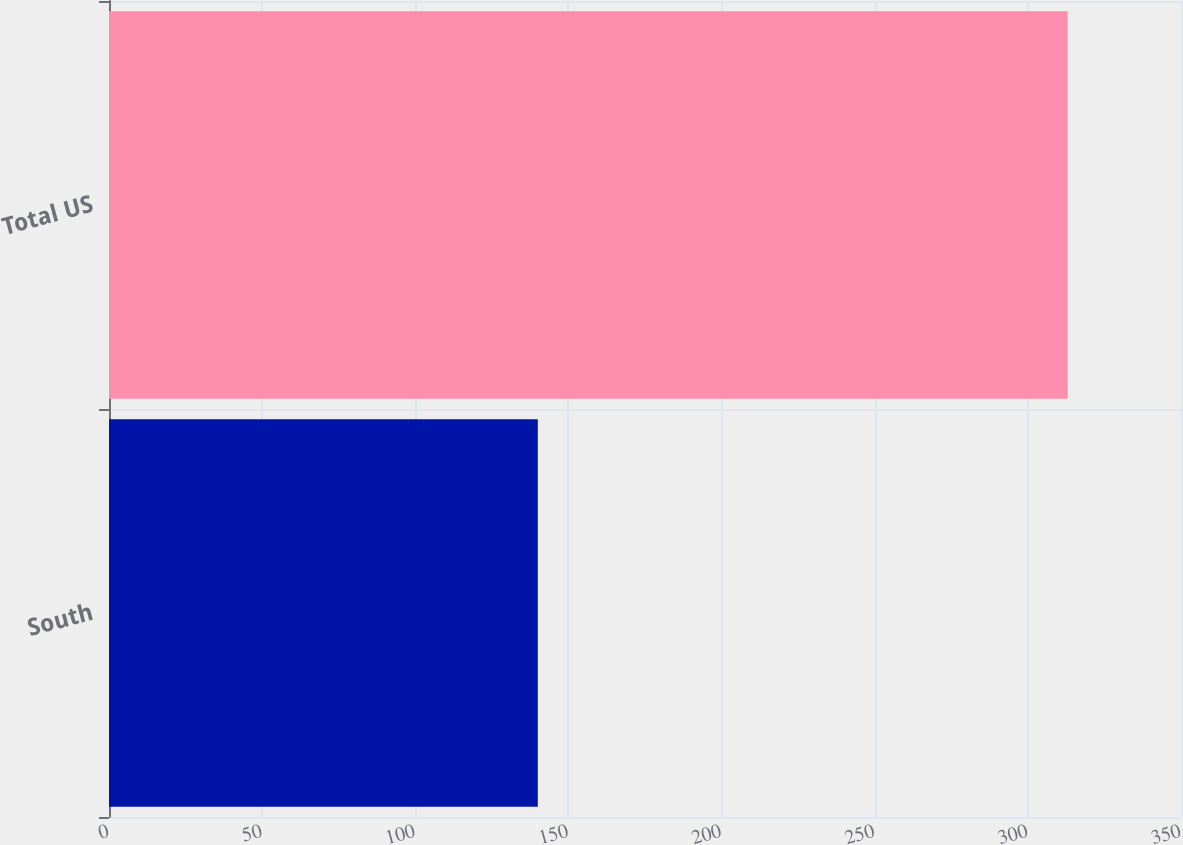<chart> <loc_0><loc_0><loc_500><loc_500><bar_chart><fcel>South<fcel>Total US<nl><fcel>140<fcel>313<nl></chart> 